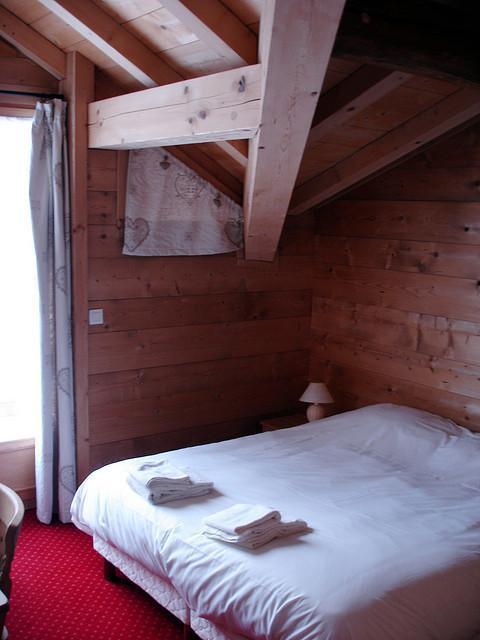How many zebras are there?
Give a very brief answer. 0. 